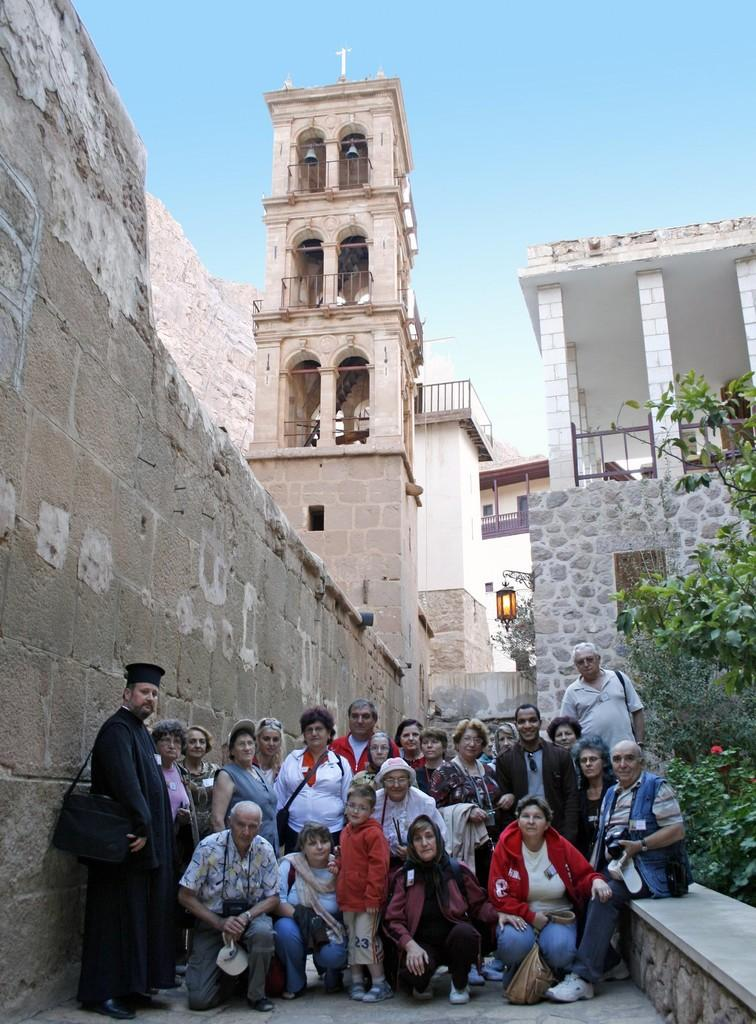What are the people in the image doing? There are people sitting and standing on the floor in the image. What can be seen in the background of the image? Buildings, electric lights, trees, plants, and the sky are visible in the background of the image. What type of neck can be seen on the buildings in the image? There are no necks present on the buildings in the image. What is the cause of the destruction in the image? There is no destruction present in the image. 